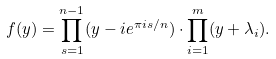Convert formula to latex. <formula><loc_0><loc_0><loc_500><loc_500>f ( y ) = \prod _ { s = 1 } ^ { n - 1 } ( y - i e ^ { \pi i s / n } ) \cdot \prod _ { i = 1 } ^ { m } ( y + \lambda _ { i } ) .</formula> 